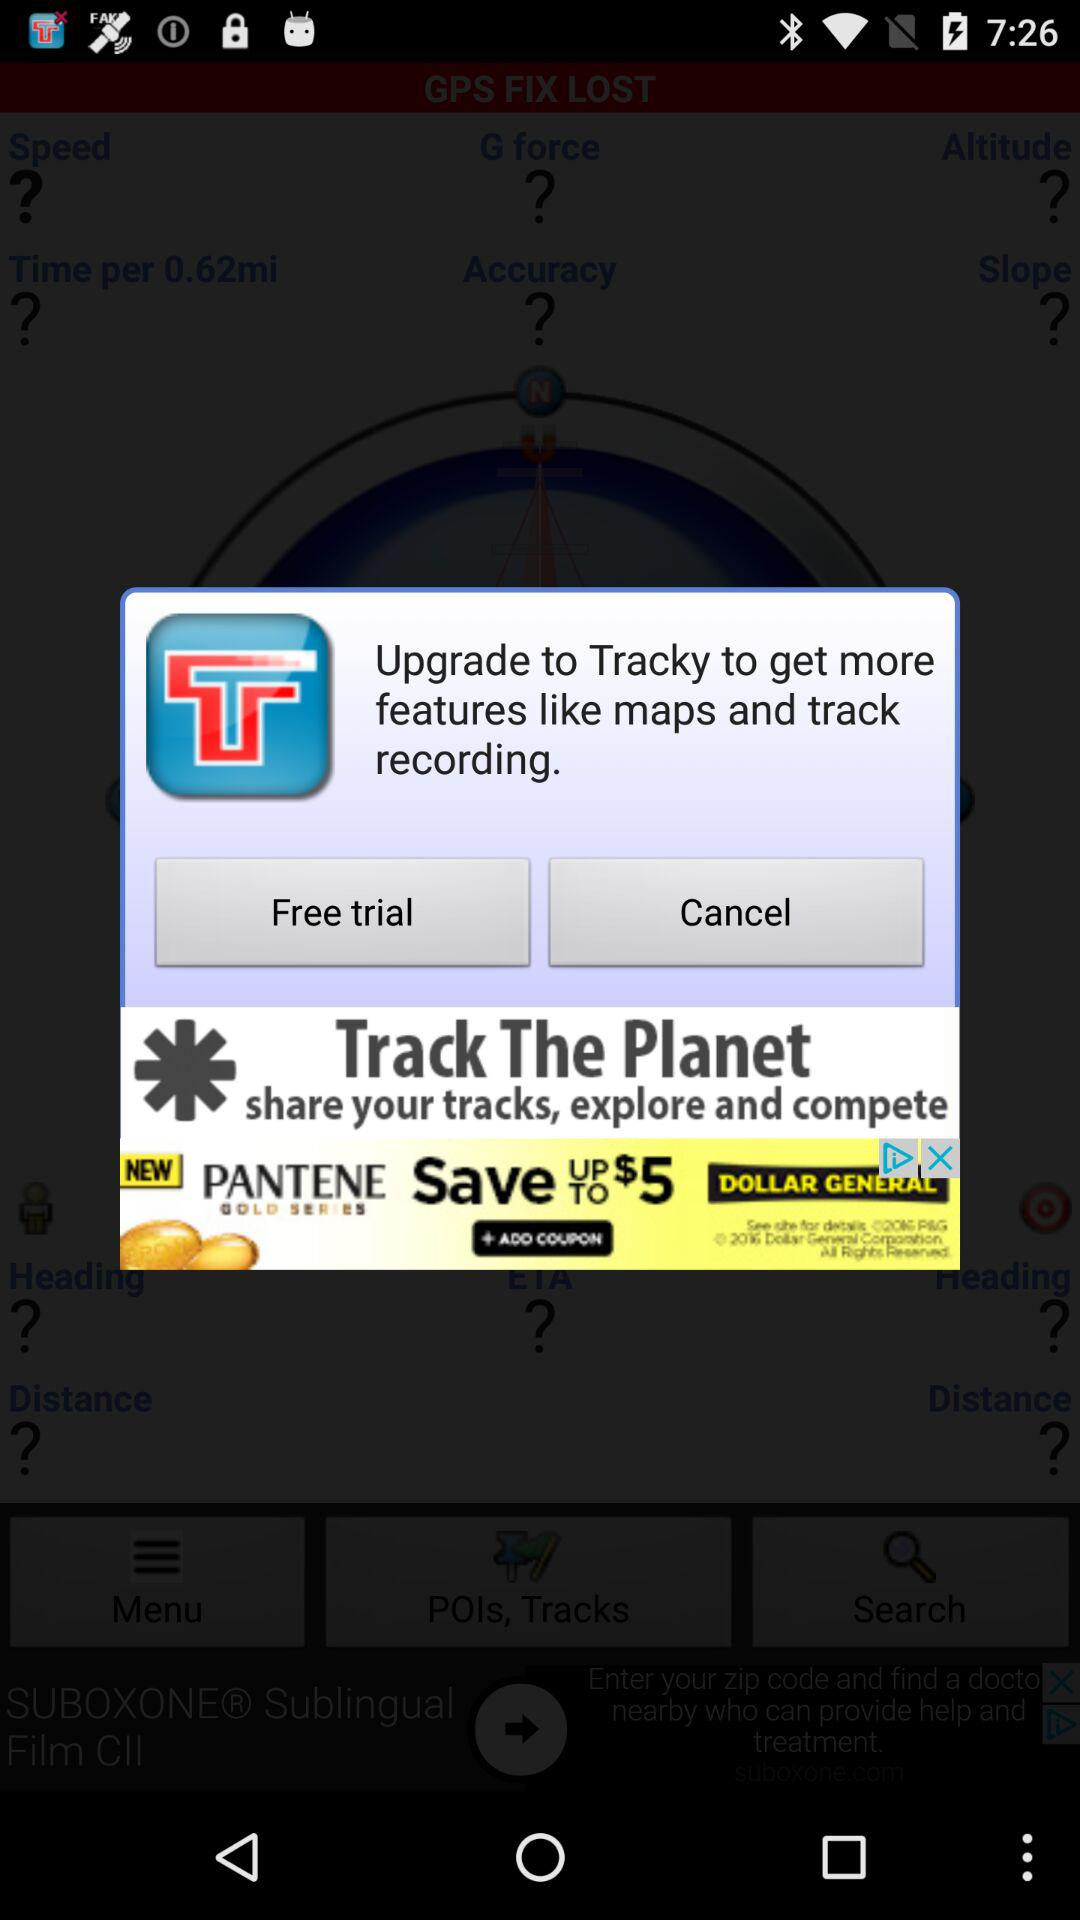What is the name of the application? The name of the application is "Tracky". 